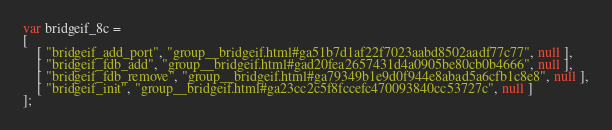Convert code to text. <code><loc_0><loc_0><loc_500><loc_500><_JavaScript_>var bridgeif_8c =
[
    [ "bridgeif_add_port", "group__bridgeif.html#ga51b7d1af22f7023aabd8502aadf77c77", null ],
    [ "bridgeif_fdb_add", "group__bridgeif.html#gad20fea2657431d4a0905be80cb0b4666", null ],
    [ "bridgeif_fdb_remove", "group__bridgeif.html#ga79349b1e9d0f944e8abad5a6cfb1c8e8", null ],
    [ "bridgeif_init", "group__bridgeif.html#ga23cc2c5f8fccefc470093840cc53727c", null ]
];</code> 